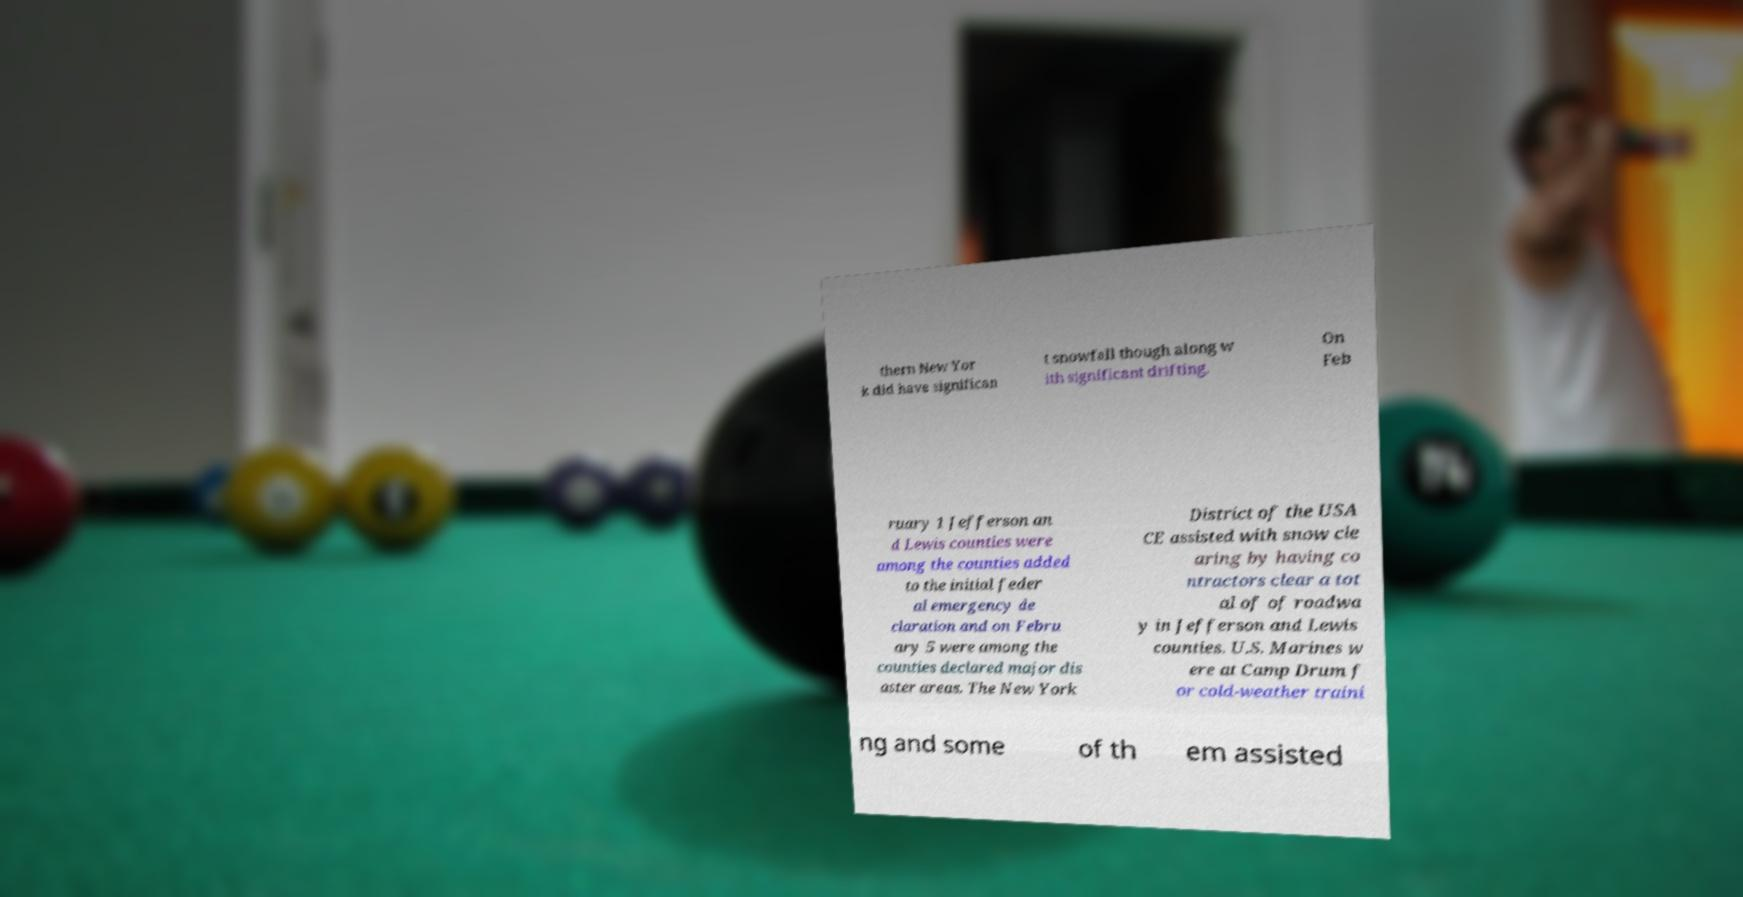What messages or text are displayed in this image? I need them in a readable, typed format. thern New Yor k did have significan t snowfall though along w ith significant drifting. On Feb ruary 1 Jefferson an d Lewis counties were among the counties added to the initial feder al emergency de claration and on Febru ary 5 were among the counties declared major dis aster areas. The New York District of the USA CE assisted with snow cle aring by having co ntractors clear a tot al of of roadwa y in Jefferson and Lewis counties. U.S. Marines w ere at Camp Drum f or cold-weather traini ng and some of th em assisted 